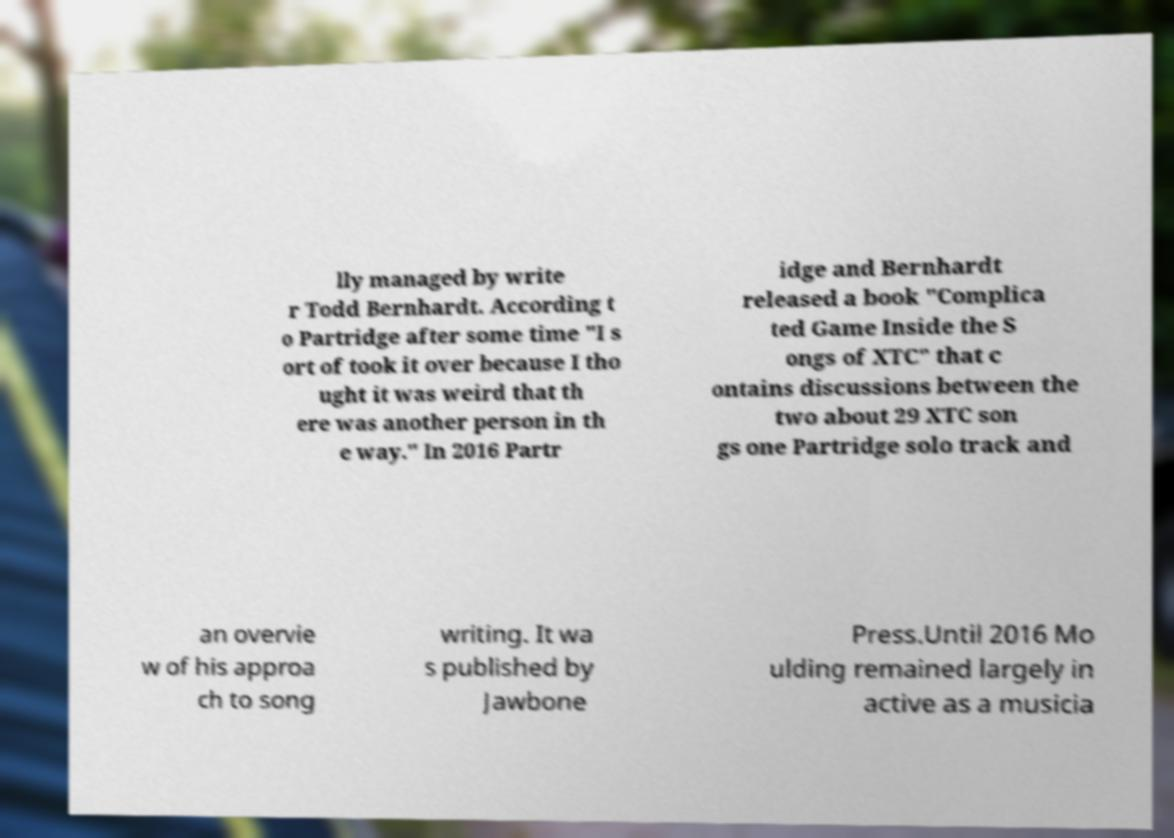Please read and relay the text visible in this image. What does it say? lly managed by write r Todd Bernhardt. According t o Partridge after some time "I s ort of took it over because I tho ught it was weird that th ere was another person in th e way." In 2016 Partr idge and Bernhardt released a book "Complica ted Game Inside the S ongs of XTC" that c ontains discussions between the two about 29 XTC son gs one Partridge solo track and an overvie w of his approa ch to song writing. It wa s published by Jawbone Press.Until 2016 Mo ulding remained largely in active as a musicia 